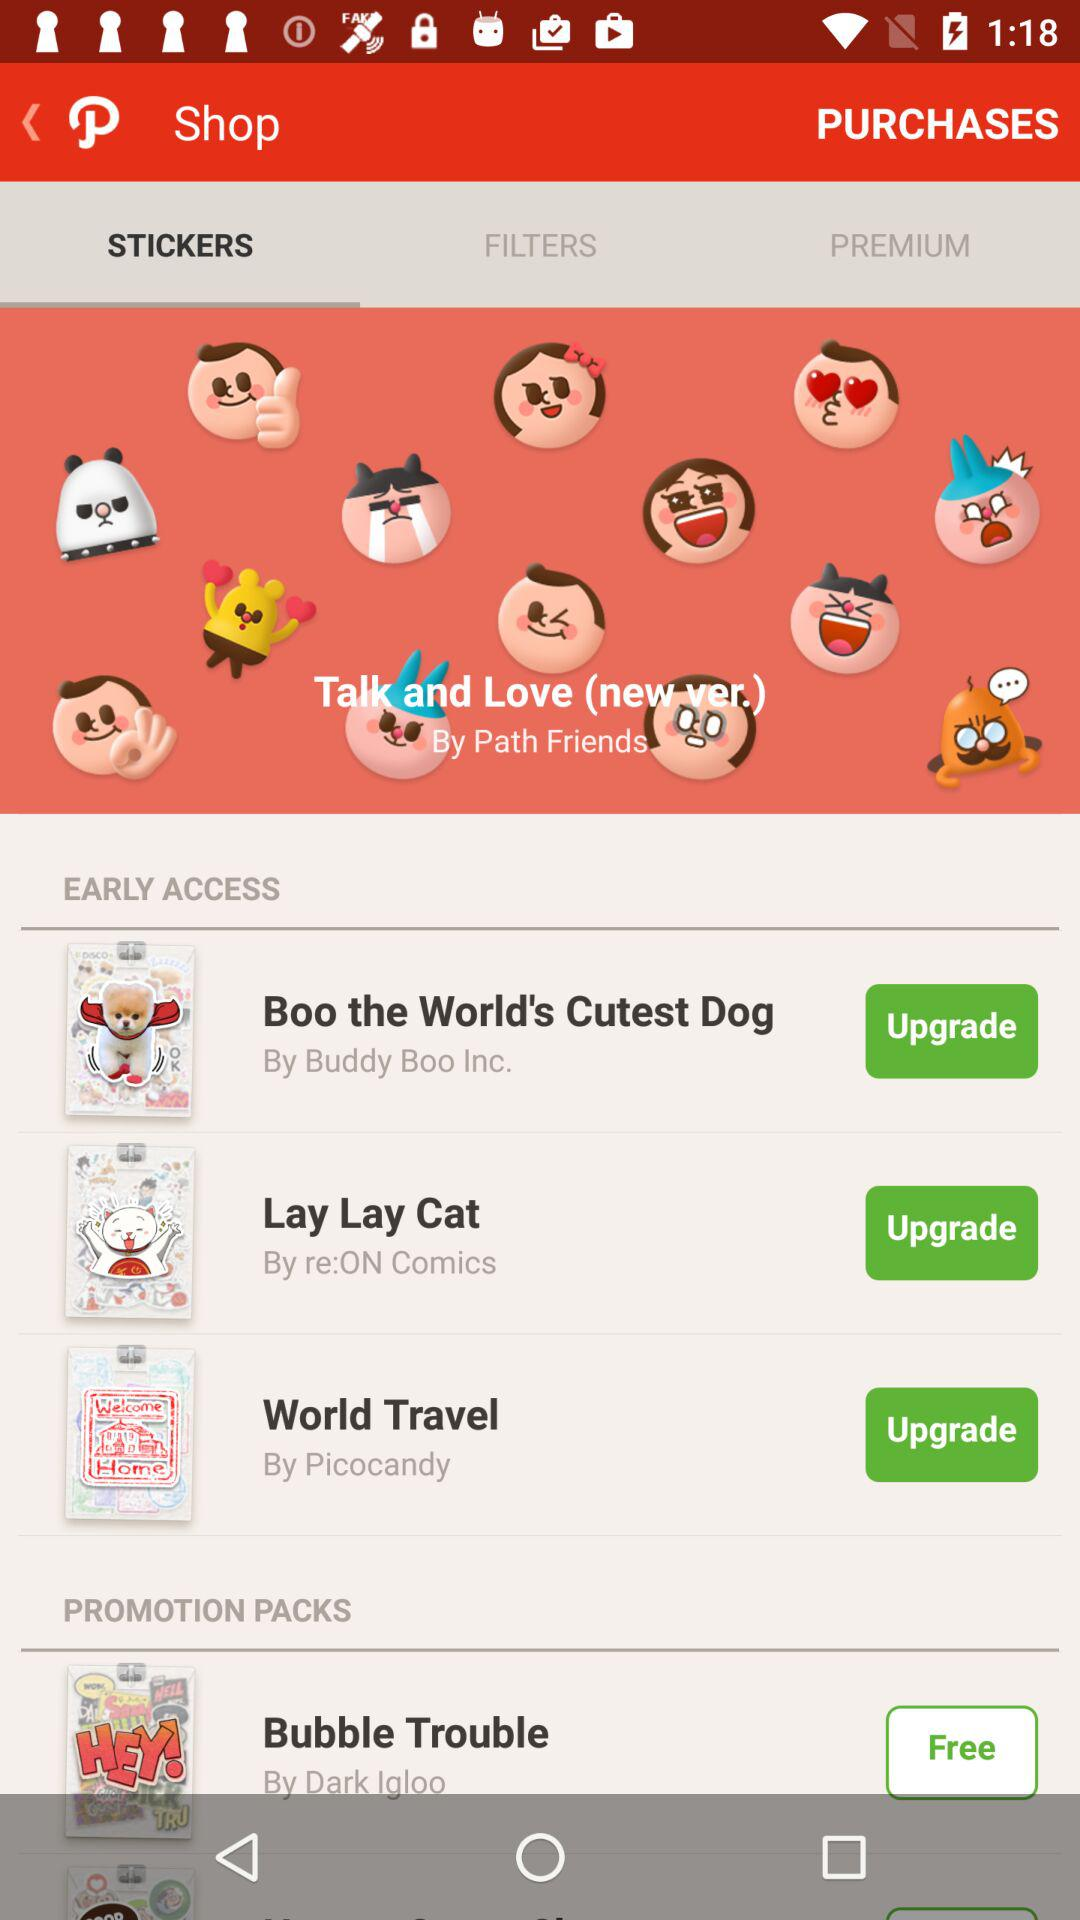Which tab is selected? The selected tab is "STICKERS". 